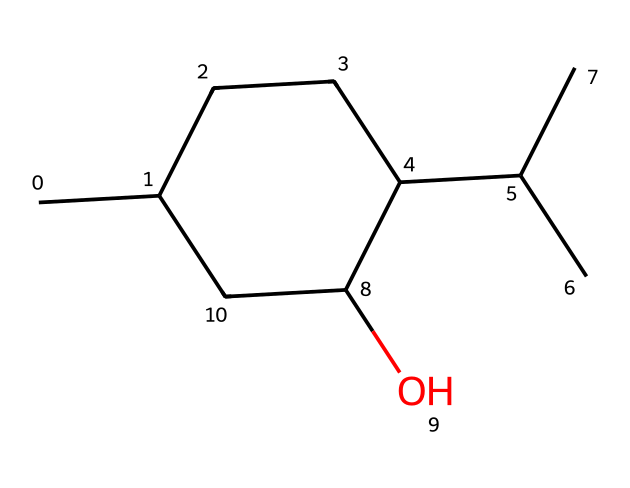What is the name of the compound represented by this SMILES? The SMILES representation corresponds to menthol, a cyclic alcohol with distinct structural characteristics. One can identify this by recognizing the carbon and oxygen atoms alongside the alcohol functional group.
Answer: menthol How many carbon atoms does menthol contain? In the SMILES representation, counting the carbon atoms shows there are 10 carbon atoms present in the cyclic structure of menthol.
Answer: 10 What type of functional group is present in the menthol structure? By examining the structure, one can identify the hydroxyl (-OH) group attached to one of the carbon atoms, classifying it as an alcohol functional group.
Answer: alcohol What type of cycloalkane is menthol classified as? Menthol is classified as a cyclic tertiary alcohol because it has a hydroxyl group attached to a carbon that is also bonded to two other carbon atoms in the ring.
Answer: tertiary cycloalkane How many hydrogen atoms are in the menthol structure? To find the number of hydrogen atoms, count the implicit hydrogen atoms based on the tetravalency of carbon and the specific bonding in the structure, confirming there are 22 hydrogen atoms in menthol.
Answer: 22 How does the cyclic structure of menthol influence its properties? The cyclic structure of menthol contributes to its unique physical properties by affecting factors such as melting and boiling points, and its interaction with biological receptors, enhancing its cooling sensation.
Answer: unique physical properties What is the degree of saturation of menthol? The degree of saturation can be evaluated by identifying the double and triple bonds in the structure; menthol is fully saturated with single bonds only, indicating a degree of saturation equal to 1.
Answer: 1 